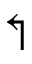<formula> <loc_0><loc_0><loc_500><loc_500>\L s h</formula> 